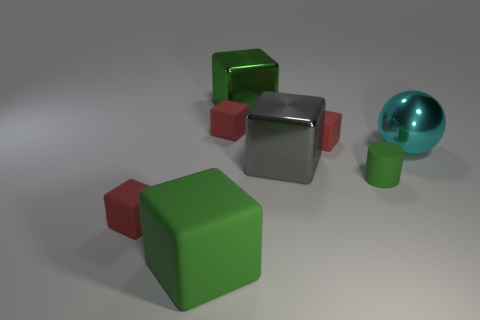There is a rubber object that is both behind the large green rubber cube and in front of the matte cylinder; what is its color?
Keep it short and to the point. Red. What is the material of the other big green object that is the same shape as the big green rubber object?
Offer a very short reply. Metal. Are there any other things that are the same size as the green rubber cylinder?
Provide a short and direct response. Yes. Is the number of metallic things greater than the number of large cyan objects?
Ensure brevity in your answer.  Yes. What size is the green object that is in front of the green shiny object and on the left side of the gray thing?
Your response must be concise. Large. The gray metal object has what shape?
Your answer should be very brief. Cube. What number of green shiny things have the same shape as the gray thing?
Give a very brief answer. 1. Is the number of big cyan metallic objects that are to the left of the gray metallic cube less than the number of gray shiny blocks that are on the right side of the large metal ball?
Ensure brevity in your answer.  No. What number of green objects are left of the green object to the left of the green metal cube?
Offer a very short reply. 0. Are any tiny rubber blocks visible?
Your answer should be compact. Yes. 